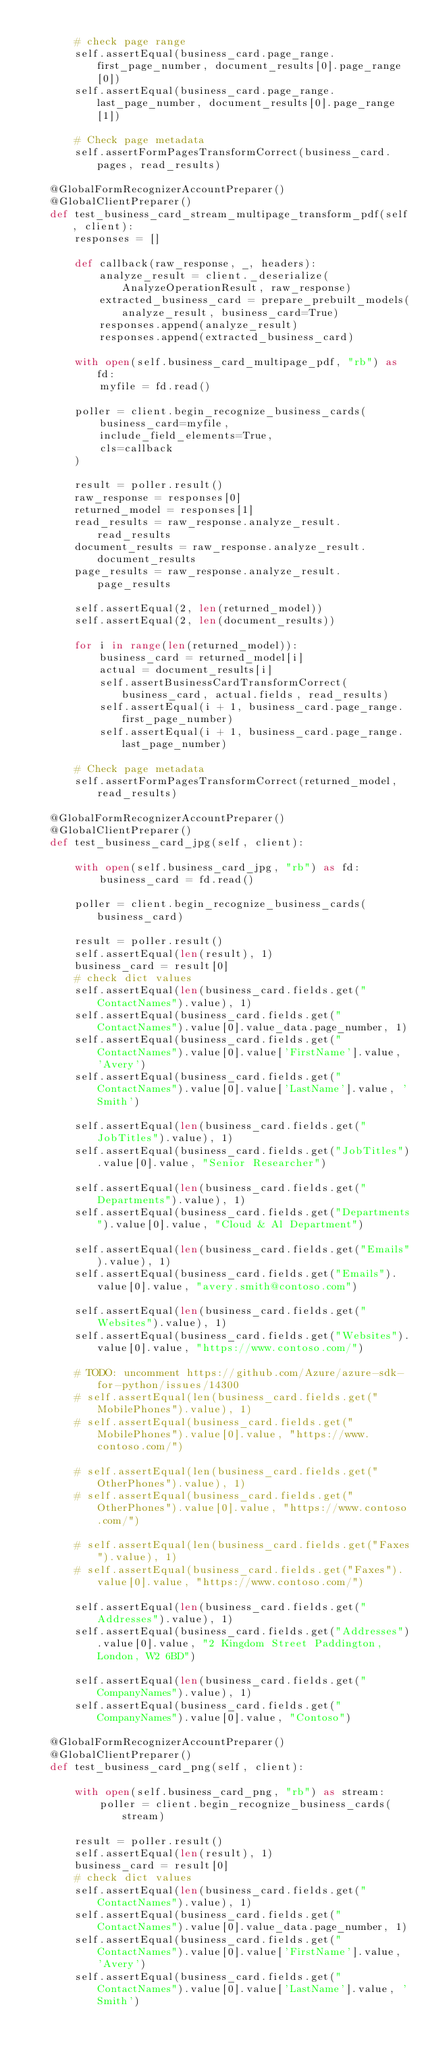<code> <loc_0><loc_0><loc_500><loc_500><_Python_>
        # check page range
        self.assertEqual(business_card.page_range.first_page_number, document_results[0].page_range[0])
        self.assertEqual(business_card.page_range.last_page_number, document_results[0].page_range[1])

        # Check page metadata
        self.assertFormPagesTransformCorrect(business_card.pages, read_results)

    @GlobalFormRecognizerAccountPreparer()
    @GlobalClientPreparer()
    def test_business_card_stream_multipage_transform_pdf(self, client):
        responses = []

        def callback(raw_response, _, headers):
            analyze_result = client._deserialize(AnalyzeOperationResult, raw_response)
            extracted_business_card = prepare_prebuilt_models(analyze_result, business_card=True)
            responses.append(analyze_result)
            responses.append(extracted_business_card)

        with open(self.business_card_multipage_pdf, "rb") as fd:
            myfile = fd.read()

        poller = client.begin_recognize_business_cards(
            business_card=myfile,
            include_field_elements=True,
            cls=callback
        )

        result = poller.result()
        raw_response = responses[0]
        returned_model = responses[1]
        read_results = raw_response.analyze_result.read_results
        document_results = raw_response.analyze_result.document_results
        page_results = raw_response.analyze_result.page_results

        self.assertEqual(2, len(returned_model))
        self.assertEqual(2, len(document_results))

        for i in range(len(returned_model)):
            business_card = returned_model[i]
            actual = document_results[i]
            self.assertBusinessCardTransformCorrect(business_card, actual.fields, read_results)
            self.assertEqual(i + 1, business_card.page_range.first_page_number)
            self.assertEqual(i + 1, business_card.page_range.last_page_number)

        # Check page metadata
        self.assertFormPagesTransformCorrect(returned_model, read_results)

    @GlobalFormRecognizerAccountPreparer()
    @GlobalClientPreparer()
    def test_business_card_jpg(self, client):

        with open(self.business_card_jpg, "rb") as fd:
            business_card = fd.read()

        poller = client.begin_recognize_business_cards(business_card)

        result = poller.result()
        self.assertEqual(len(result), 1)
        business_card = result[0]
        # check dict values
        self.assertEqual(len(business_card.fields.get("ContactNames").value), 1)
        self.assertEqual(business_card.fields.get("ContactNames").value[0].value_data.page_number, 1)
        self.assertEqual(business_card.fields.get("ContactNames").value[0].value['FirstName'].value, 'Avery')
        self.assertEqual(business_card.fields.get("ContactNames").value[0].value['LastName'].value, 'Smith')

        self.assertEqual(len(business_card.fields.get("JobTitles").value), 1)
        self.assertEqual(business_card.fields.get("JobTitles").value[0].value, "Senior Researcher")

        self.assertEqual(len(business_card.fields.get("Departments").value), 1)
        self.assertEqual(business_card.fields.get("Departments").value[0].value, "Cloud & Al Department")

        self.assertEqual(len(business_card.fields.get("Emails").value), 1)
        self.assertEqual(business_card.fields.get("Emails").value[0].value, "avery.smith@contoso.com")

        self.assertEqual(len(business_card.fields.get("Websites").value), 1)
        self.assertEqual(business_card.fields.get("Websites").value[0].value, "https://www.contoso.com/")

        # TODO: uncomment https://github.com/Azure/azure-sdk-for-python/issues/14300
        # self.assertEqual(len(business_card.fields.get("MobilePhones").value), 1)
        # self.assertEqual(business_card.fields.get("MobilePhones").value[0].value, "https://www.contoso.com/")

        # self.assertEqual(len(business_card.fields.get("OtherPhones").value), 1)
        # self.assertEqual(business_card.fields.get("OtherPhones").value[0].value, "https://www.contoso.com/")

        # self.assertEqual(len(business_card.fields.get("Faxes").value), 1)
        # self.assertEqual(business_card.fields.get("Faxes").value[0].value, "https://www.contoso.com/")

        self.assertEqual(len(business_card.fields.get("Addresses").value), 1)
        self.assertEqual(business_card.fields.get("Addresses").value[0].value, "2 Kingdom Street Paddington, London, W2 6BD")

        self.assertEqual(len(business_card.fields.get("CompanyNames").value), 1)
        self.assertEqual(business_card.fields.get("CompanyNames").value[0].value, "Contoso")

    @GlobalFormRecognizerAccountPreparer()
    @GlobalClientPreparer()
    def test_business_card_png(self, client):

        with open(self.business_card_png, "rb") as stream:
            poller = client.begin_recognize_business_cards(stream)

        result = poller.result()
        self.assertEqual(len(result), 1)
        business_card = result[0]
        # check dict values
        self.assertEqual(len(business_card.fields.get("ContactNames").value), 1)
        self.assertEqual(business_card.fields.get("ContactNames").value[0].value_data.page_number, 1)
        self.assertEqual(business_card.fields.get("ContactNames").value[0].value['FirstName'].value, 'Avery')
        self.assertEqual(business_card.fields.get("ContactNames").value[0].value['LastName'].value, 'Smith')
</code> 